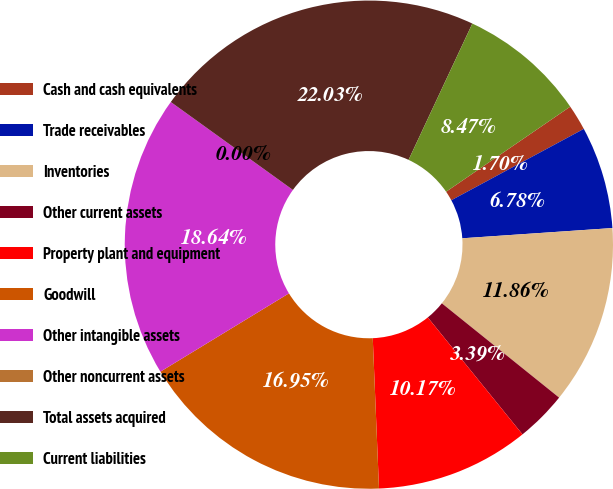Convert chart to OTSL. <chart><loc_0><loc_0><loc_500><loc_500><pie_chart><fcel>Cash and cash equivalents<fcel>Trade receivables<fcel>Inventories<fcel>Other current assets<fcel>Property plant and equipment<fcel>Goodwill<fcel>Other intangible assets<fcel>Other noncurrent assets<fcel>Total assets acquired<fcel>Current liabilities<nl><fcel>1.7%<fcel>6.78%<fcel>11.86%<fcel>3.39%<fcel>10.17%<fcel>16.95%<fcel>18.64%<fcel>0.0%<fcel>22.03%<fcel>8.47%<nl></chart> 